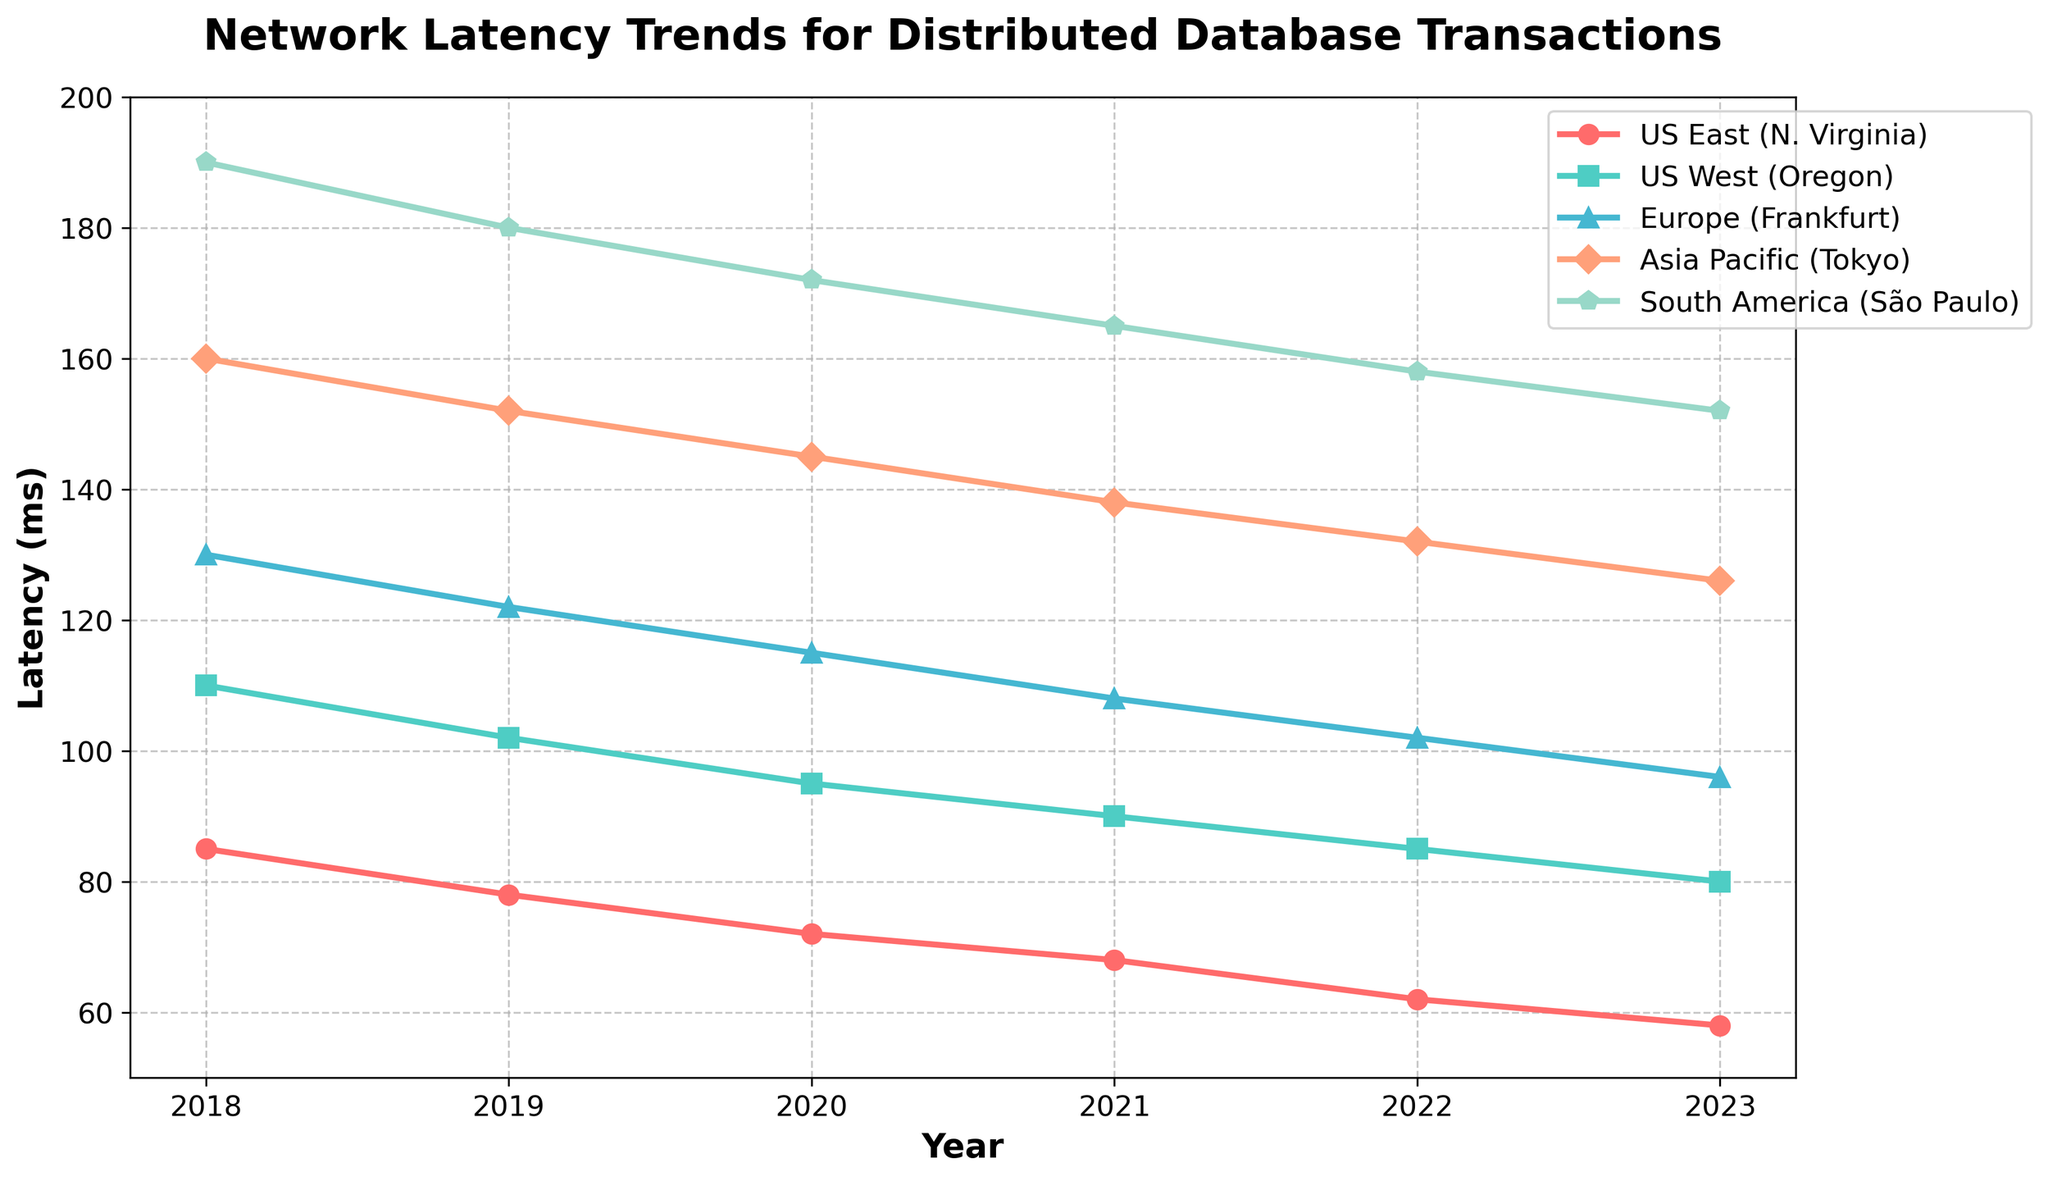What's the trend in network latency for the US East (N. Virginia) region from 2018 to 2023? To answer this question, we need to observe how the line representing "US East (N. Virginia)" changes over the years. The line starts at 85 ms in 2018 and gradually decreases each year, reaching 58 ms by 2023. The trend shows a consistent decrease.
Answer: Consistent decrease Which data center has the highest network latency in 2023? To determine this, we look at the ending points of all the lines for the year 2023. The highest point corresponds to the "South America (São Paulo)" region ending at 152 ms.
Answer: South America (São Paulo) In which year did the US West (Oregon) region see the biggest decrease in latency? We need to look for the steepest decline between two consecutive years for "US West (Oregon)". Between 2018 and 2019, the latency drops from 110 ms to 102 ms, a decrease of 8 ms. This is the largest drop compared to other years.
Answer: 2018-2019 What is the average network latency for Europe (Frankfurt) from 2019 to 2023? Sum the latencies for Europe (Frankfurt) from 2019 to 2023: 122 + 115 + 108 + 102 + 96 = 543 ms. Divide by the number of years: 543 ms / 5 = 108.6 ms.
Answer: 108.6 ms Which region had the smallest latency in 2021, and what was it? Identify the lowest point in 2021 by comparing the latencies for 2021. "US East (N. Virginia)" has the smallest latency at 68 ms.
Answer: US East (N. Virginia), 68 ms How does the latency difference between Asia Pacific (Tokyo) and US East (N. Virginia) change from 2018 to 2023? Calculate the difference for each year:
2018: 160 - 85 = 75 ms
2023: 126 - 58 = 68 ms
The difference decreases by (75 - 68) = 7 ms over this period.
Answer: Decreases by 7 ms Which two regions show the most similar latency trends over the years? Compare the slopes and shapes of the lines visually. "US West (Oregon)" and "Europe (Frankfurt)" show comparable downward trends with similar shapes and changes in latency.
Answer: US West (Oregon) and Europe (Frankfurt) In which year did South America (São Paulo) achieve under 160 ms latency for the first time? Examine the points for "South America (São Paulo)" each year to find where it goes below 160 ms. It first drops below 160 ms in 2022.
Answer: 2022 